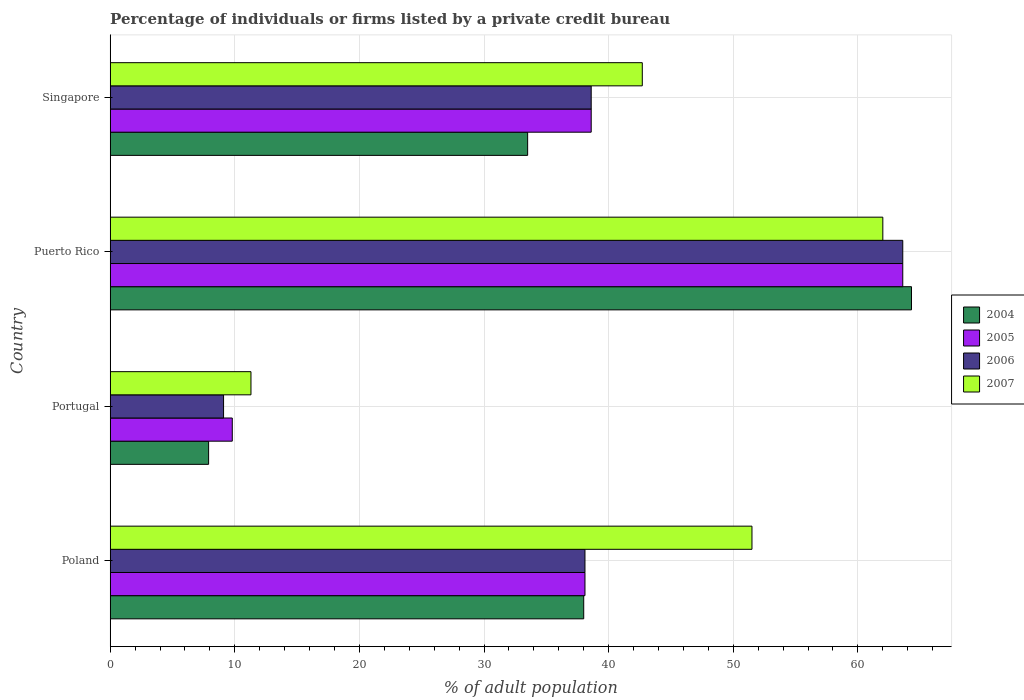How many different coloured bars are there?
Ensure brevity in your answer.  4. How many groups of bars are there?
Your answer should be very brief. 4. Are the number of bars on each tick of the Y-axis equal?
Your answer should be compact. Yes. How many bars are there on the 1st tick from the bottom?
Your answer should be compact. 4. What is the label of the 1st group of bars from the top?
Your answer should be very brief. Singapore. In how many cases, is the number of bars for a given country not equal to the number of legend labels?
Offer a very short reply. 0. What is the percentage of population listed by a private credit bureau in 2005 in Puerto Rico?
Provide a short and direct response. 63.6. Across all countries, what is the maximum percentage of population listed by a private credit bureau in 2007?
Ensure brevity in your answer.  62. Across all countries, what is the minimum percentage of population listed by a private credit bureau in 2006?
Keep it short and to the point. 9.1. In which country was the percentage of population listed by a private credit bureau in 2006 maximum?
Offer a very short reply. Puerto Rico. In which country was the percentage of population listed by a private credit bureau in 2004 minimum?
Make the answer very short. Portugal. What is the total percentage of population listed by a private credit bureau in 2004 in the graph?
Offer a very short reply. 143.7. What is the difference between the percentage of population listed by a private credit bureau in 2004 in Puerto Rico and the percentage of population listed by a private credit bureau in 2007 in Singapore?
Give a very brief answer. 21.6. What is the average percentage of population listed by a private credit bureau in 2005 per country?
Provide a short and direct response. 37.52. What is the difference between the percentage of population listed by a private credit bureau in 2007 and percentage of population listed by a private credit bureau in 2006 in Portugal?
Keep it short and to the point. 2.2. What is the ratio of the percentage of population listed by a private credit bureau in 2004 in Puerto Rico to that in Singapore?
Your answer should be compact. 1.92. Is the percentage of population listed by a private credit bureau in 2005 in Poland less than that in Puerto Rico?
Your answer should be very brief. Yes. Is the difference between the percentage of population listed by a private credit bureau in 2007 in Portugal and Puerto Rico greater than the difference between the percentage of population listed by a private credit bureau in 2006 in Portugal and Puerto Rico?
Your response must be concise. Yes. What is the difference between the highest and the lowest percentage of population listed by a private credit bureau in 2007?
Make the answer very short. 50.7. Is it the case that in every country, the sum of the percentage of population listed by a private credit bureau in 2005 and percentage of population listed by a private credit bureau in 2006 is greater than the sum of percentage of population listed by a private credit bureau in 2007 and percentage of population listed by a private credit bureau in 2004?
Your answer should be very brief. No. Is it the case that in every country, the sum of the percentage of population listed by a private credit bureau in 2007 and percentage of population listed by a private credit bureau in 2006 is greater than the percentage of population listed by a private credit bureau in 2004?
Provide a short and direct response. Yes. Are all the bars in the graph horizontal?
Ensure brevity in your answer.  Yes. How many countries are there in the graph?
Ensure brevity in your answer.  4. Are the values on the major ticks of X-axis written in scientific E-notation?
Offer a very short reply. No. Where does the legend appear in the graph?
Give a very brief answer. Center right. What is the title of the graph?
Your response must be concise. Percentage of individuals or firms listed by a private credit bureau. What is the label or title of the X-axis?
Ensure brevity in your answer.  % of adult population. What is the label or title of the Y-axis?
Give a very brief answer. Country. What is the % of adult population of 2005 in Poland?
Ensure brevity in your answer.  38.1. What is the % of adult population in 2006 in Poland?
Your answer should be very brief. 38.1. What is the % of adult population in 2007 in Poland?
Keep it short and to the point. 51.5. What is the % of adult population in 2004 in Puerto Rico?
Your response must be concise. 64.3. What is the % of adult population of 2005 in Puerto Rico?
Your response must be concise. 63.6. What is the % of adult population in 2006 in Puerto Rico?
Offer a terse response. 63.6. What is the % of adult population in 2007 in Puerto Rico?
Your answer should be very brief. 62. What is the % of adult population in 2004 in Singapore?
Offer a very short reply. 33.5. What is the % of adult population in 2005 in Singapore?
Your response must be concise. 38.6. What is the % of adult population in 2006 in Singapore?
Ensure brevity in your answer.  38.6. What is the % of adult population in 2007 in Singapore?
Provide a short and direct response. 42.7. Across all countries, what is the maximum % of adult population in 2004?
Make the answer very short. 64.3. Across all countries, what is the maximum % of adult population in 2005?
Provide a short and direct response. 63.6. Across all countries, what is the maximum % of adult population in 2006?
Offer a terse response. 63.6. Across all countries, what is the minimum % of adult population in 2005?
Provide a short and direct response. 9.8. Across all countries, what is the minimum % of adult population of 2006?
Provide a short and direct response. 9.1. Across all countries, what is the minimum % of adult population in 2007?
Offer a very short reply. 11.3. What is the total % of adult population in 2004 in the graph?
Make the answer very short. 143.7. What is the total % of adult population of 2005 in the graph?
Give a very brief answer. 150.1. What is the total % of adult population of 2006 in the graph?
Keep it short and to the point. 149.4. What is the total % of adult population of 2007 in the graph?
Ensure brevity in your answer.  167.5. What is the difference between the % of adult population in 2004 in Poland and that in Portugal?
Your answer should be very brief. 30.1. What is the difference between the % of adult population of 2005 in Poland and that in Portugal?
Keep it short and to the point. 28.3. What is the difference between the % of adult population of 2007 in Poland and that in Portugal?
Offer a terse response. 40.2. What is the difference between the % of adult population in 2004 in Poland and that in Puerto Rico?
Ensure brevity in your answer.  -26.3. What is the difference between the % of adult population of 2005 in Poland and that in Puerto Rico?
Your answer should be compact. -25.5. What is the difference between the % of adult population in 2006 in Poland and that in Puerto Rico?
Your answer should be very brief. -25.5. What is the difference between the % of adult population of 2007 in Poland and that in Puerto Rico?
Provide a succinct answer. -10.5. What is the difference between the % of adult population in 2004 in Poland and that in Singapore?
Offer a very short reply. 4.5. What is the difference between the % of adult population in 2006 in Poland and that in Singapore?
Give a very brief answer. -0.5. What is the difference between the % of adult population in 2004 in Portugal and that in Puerto Rico?
Provide a succinct answer. -56.4. What is the difference between the % of adult population of 2005 in Portugal and that in Puerto Rico?
Provide a short and direct response. -53.8. What is the difference between the % of adult population of 2006 in Portugal and that in Puerto Rico?
Keep it short and to the point. -54.5. What is the difference between the % of adult population in 2007 in Portugal and that in Puerto Rico?
Your answer should be compact. -50.7. What is the difference between the % of adult population in 2004 in Portugal and that in Singapore?
Give a very brief answer. -25.6. What is the difference between the % of adult population in 2005 in Portugal and that in Singapore?
Your answer should be compact. -28.8. What is the difference between the % of adult population in 2006 in Portugal and that in Singapore?
Provide a succinct answer. -29.5. What is the difference between the % of adult population of 2007 in Portugal and that in Singapore?
Your answer should be very brief. -31.4. What is the difference between the % of adult population of 2004 in Puerto Rico and that in Singapore?
Make the answer very short. 30.8. What is the difference between the % of adult population in 2005 in Puerto Rico and that in Singapore?
Give a very brief answer. 25. What is the difference between the % of adult population in 2006 in Puerto Rico and that in Singapore?
Your response must be concise. 25. What is the difference between the % of adult population in 2007 in Puerto Rico and that in Singapore?
Ensure brevity in your answer.  19.3. What is the difference between the % of adult population in 2004 in Poland and the % of adult population in 2005 in Portugal?
Keep it short and to the point. 28.2. What is the difference between the % of adult population in 2004 in Poland and the % of adult population in 2006 in Portugal?
Give a very brief answer. 28.9. What is the difference between the % of adult population of 2004 in Poland and the % of adult population of 2007 in Portugal?
Ensure brevity in your answer.  26.7. What is the difference between the % of adult population in 2005 in Poland and the % of adult population in 2007 in Portugal?
Offer a very short reply. 26.8. What is the difference between the % of adult population in 2006 in Poland and the % of adult population in 2007 in Portugal?
Offer a very short reply. 26.8. What is the difference between the % of adult population of 2004 in Poland and the % of adult population of 2005 in Puerto Rico?
Offer a terse response. -25.6. What is the difference between the % of adult population in 2004 in Poland and the % of adult population in 2006 in Puerto Rico?
Provide a succinct answer. -25.6. What is the difference between the % of adult population in 2005 in Poland and the % of adult population in 2006 in Puerto Rico?
Provide a short and direct response. -25.5. What is the difference between the % of adult population in 2005 in Poland and the % of adult population in 2007 in Puerto Rico?
Provide a succinct answer. -23.9. What is the difference between the % of adult population in 2006 in Poland and the % of adult population in 2007 in Puerto Rico?
Your answer should be compact. -23.9. What is the difference between the % of adult population of 2004 in Poland and the % of adult population of 2005 in Singapore?
Ensure brevity in your answer.  -0.6. What is the difference between the % of adult population in 2005 in Poland and the % of adult population in 2006 in Singapore?
Your answer should be very brief. -0.5. What is the difference between the % of adult population in 2005 in Poland and the % of adult population in 2007 in Singapore?
Your answer should be compact. -4.6. What is the difference between the % of adult population in 2006 in Poland and the % of adult population in 2007 in Singapore?
Ensure brevity in your answer.  -4.6. What is the difference between the % of adult population of 2004 in Portugal and the % of adult population of 2005 in Puerto Rico?
Keep it short and to the point. -55.7. What is the difference between the % of adult population in 2004 in Portugal and the % of adult population in 2006 in Puerto Rico?
Offer a terse response. -55.7. What is the difference between the % of adult population of 2004 in Portugal and the % of adult population of 2007 in Puerto Rico?
Your response must be concise. -54.1. What is the difference between the % of adult population in 2005 in Portugal and the % of adult population in 2006 in Puerto Rico?
Your response must be concise. -53.8. What is the difference between the % of adult population of 2005 in Portugal and the % of adult population of 2007 in Puerto Rico?
Your answer should be compact. -52.2. What is the difference between the % of adult population in 2006 in Portugal and the % of adult population in 2007 in Puerto Rico?
Provide a succinct answer. -52.9. What is the difference between the % of adult population of 2004 in Portugal and the % of adult population of 2005 in Singapore?
Your answer should be very brief. -30.7. What is the difference between the % of adult population in 2004 in Portugal and the % of adult population in 2006 in Singapore?
Your response must be concise. -30.7. What is the difference between the % of adult population in 2004 in Portugal and the % of adult population in 2007 in Singapore?
Keep it short and to the point. -34.8. What is the difference between the % of adult population of 2005 in Portugal and the % of adult population of 2006 in Singapore?
Your response must be concise. -28.8. What is the difference between the % of adult population in 2005 in Portugal and the % of adult population in 2007 in Singapore?
Keep it short and to the point. -32.9. What is the difference between the % of adult population of 2006 in Portugal and the % of adult population of 2007 in Singapore?
Your answer should be very brief. -33.6. What is the difference between the % of adult population of 2004 in Puerto Rico and the % of adult population of 2005 in Singapore?
Ensure brevity in your answer.  25.7. What is the difference between the % of adult population in 2004 in Puerto Rico and the % of adult population in 2006 in Singapore?
Offer a terse response. 25.7. What is the difference between the % of adult population of 2004 in Puerto Rico and the % of adult population of 2007 in Singapore?
Offer a very short reply. 21.6. What is the difference between the % of adult population of 2005 in Puerto Rico and the % of adult population of 2006 in Singapore?
Offer a very short reply. 25. What is the difference between the % of adult population of 2005 in Puerto Rico and the % of adult population of 2007 in Singapore?
Your answer should be very brief. 20.9. What is the difference between the % of adult population in 2006 in Puerto Rico and the % of adult population in 2007 in Singapore?
Provide a succinct answer. 20.9. What is the average % of adult population of 2004 per country?
Your answer should be very brief. 35.92. What is the average % of adult population in 2005 per country?
Your response must be concise. 37.52. What is the average % of adult population in 2006 per country?
Make the answer very short. 37.35. What is the average % of adult population of 2007 per country?
Make the answer very short. 41.88. What is the difference between the % of adult population of 2004 and % of adult population of 2006 in Poland?
Provide a succinct answer. -0.1. What is the difference between the % of adult population in 2005 and % of adult population in 2007 in Poland?
Offer a very short reply. -13.4. What is the difference between the % of adult population of 2004 and % of adult population of 2007 in Portugal?
Provide a succinct answer. -3.4. What is the difference between the % of adult population of 2005 and % of adult population of 2006 in Puerto Rico?
Keep it short and to the point. 0. What is the difference between the % of adult population of 2006 and % of adult population of 2007 in Puerto Rico?
Your answer should be compact. 1.6. What is the difference between the % of adult population of 2004 and % of adult population of 2006 in Singapore?
Make the answer very short. -5.1. What is the difference between the % of adult population in 2004 and % of adult population in 2007 in Singapore?
Ensure brevity in your answer.  -9.2. What is the difference between the % of adult population in 2006 and % of adult population in 2007 in Singapore?
Your answer should be very brief. -4.1. What is the ratio of the % of adult population in 2004 in Poland to that in Portugal?
Provide a succinct answer. 4.81. What is the ratio of the % of adult population in 2005 in Poland to that in Portugal?
Your answer should be compact. 3.89. What is the ratio of the % of adult population in 2006 in Poland to that in Portugal?
Offer a terse response. 4.19. What is the ratio of the % of adult population in 2007 in Poland to that in Portugal?
Keep it short and to the point. 4.56. What is the ratio of the % of adult population of 2004 in Poland to that in Puerto Rico?
Provide a succinct answer. 0.59. What is the ratio of the % of adult population of 2005 in Poland to that in Puerto Rico?
Your answer should be compact. 0.6. What is the ratio of the % of adult population in 2006 in Poland to that in Puerto Rico?
Your answer should be very brief. 0.6. What is the ratio of the % of adult population of 2007 in Poland to that in Puerto Rico?
Offer a very short reply. 0.83. What is the ratio of the % of adult population in 2004 in Poland to that in Singapore?
Make the answer very short. 1.13. What is the ratio of the % of adult population of 2006 in Poland to that in Singapore?
Provide a short and direct response. 0.99. What is the ratio of the % of adult population in 2007 in Poland to that in Singapore?
Provide a short and direct response. 1.21. What is the ratio of the % of adult population of 2004 in Portugal to that in Puerto Rico?
Provide a succinct answer. 0.12. What is the ratio of the % of adult population in 2005 in Portugal to that in Puerto Rico?
Offer a very short reply. 0.15. What is the ratio of the % of adult population in 2006 in Portugal to that in Puerto Rico?
Your response must be concise. 0.14. What is the ratio of the % of adult population of 2007 in Portugal to that in Puerto Rico?
Make the answer very short. 0.18. What is the ratio of the % of adult population of 2004 in Portugal to that in Singapore?
Make the answer very short. 0.24. What is the ratio of the % of adult population of 2005 in Portugal to that in Singapore?
Your answer should be very brief. 0.25. What is the ratio of the % of adult population in 2006 in Portugal to that in Singapore?
Provide a succinct answer. 0.24. What is the ratio of the % of adult population in 2007 in Portugal to that in Singapore?
Your response must be concise. 0.26. What is the ratio of the % of adult population in 2004 in Puerto Rico to that in Singapore?
Give a very brief answer. 1.92. What is the ratio of the % of adult population of 2005 in Puerto Rico to that in Singapore?
Provide a succinct answer. 1.65. What is the ratio of the % of adult population in 2006 in Puerto Rico to that in Singapore?
Keep it short and to the point. 1.65. What is the ratio of the % of adult population of 2007 in Puerto Rico to that in Singapore?
Offer a terse response. 1.45. What is the difference between the highest and the second highest % of adult population of 2004?
Your answer should be compact. 26.3. What is the difference between the highest and the second highest % of adult population of 2005?
Ensure brevity in your answer.  25. What is the difference between the highest and the second highest % of adult population of 2006?
Give a very brief answer. 25. What is the difference between the highest and the lowest % of adult population of 2004?
Your response must be concise. 56.4. What is the difference between the highest and the lowest % of adult population in 2005?
Make the answer very short. 53.8. What is the difference between the highest and the lowest % of adult population in 2006?
Offer a very short reply. 54.5. What is the difference between the highest and the lowest % of adult population of 2007?
Your answer should be compact. 50.7. 